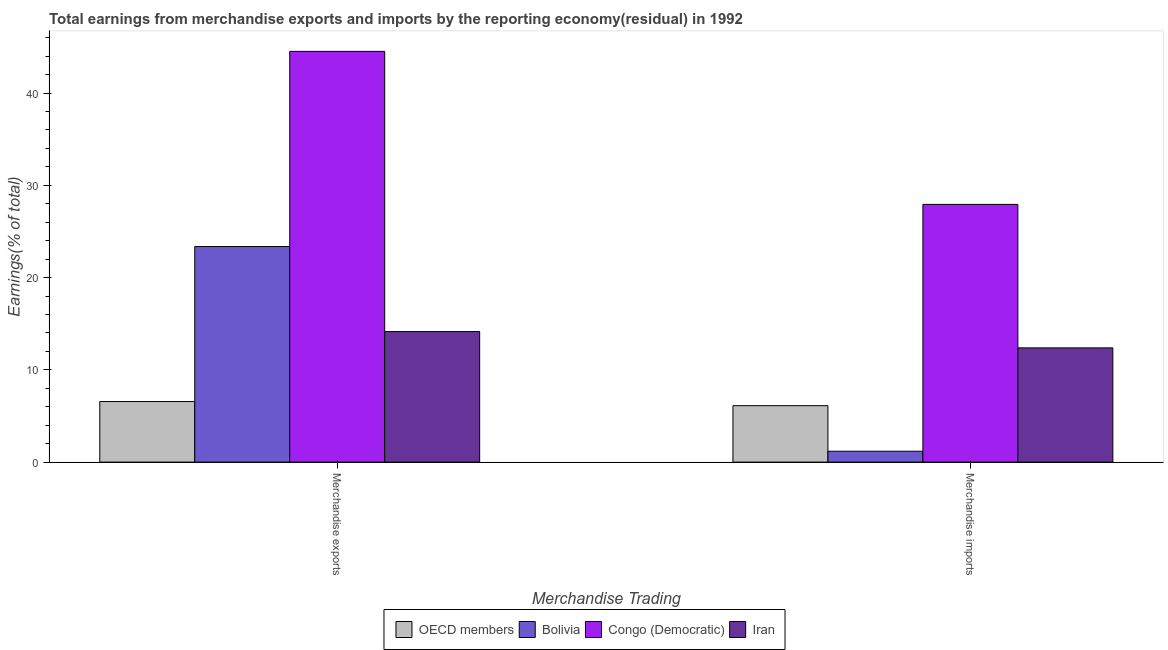How many different coloured bars are there?
Give a very brief answer. 4. How many groups of bars are there?
Provide a succinct answer. 2. Are the number of bars per tick equal to the number of legend labels?
Offer a terse response. Yes. Are the number of bars on each tick of the X-axis equal?
Offer a terse response. Yes. How many bars are there on the 1st tick from the left?
Your response must be concise. 4. How many bars are there on the 1st tick from the right?
Your answer should be compact. 4. What is the earnings from merchandise exports in Bolivia?
Offer a terse response. 23.36. Across all countries, what is the maximum earnings from merchandise imports?
Provide a short and direct response. 27.93. Across all countries, what is the minimum earnings from merchandise exports?
Provide a succinct answer. 6.57. In which country was the earnings from merchandise exports maximum?
Your answer should be compact. Congo (Democratic). In which country was the earnings from merchandise exports minimum?
Offer a very short reply. OECD members. What is the total earnings from merchandise exports in the graph?
Your answer should be compact. 88.58. What is the difference between the earnings from merchandise imports in OECD members and that in Congo (Democratic)?
Keep it short and to the point. -21.81. What is the difference between the earnings from merchandise exports in Bolivia and the earnings from merchandise imports in OECD members?
Provide a succinct answer. 17.24. What is the average earnings from merchandise exports per country?
Offer a terse response. 22.15. What is the difference between the earnings from merchandise exports and earnings from merchandise imports in OECD members?
Give a very brief answer. 0.45. What is the ratio of the earnings from merchandise exports in Bolivia to that in OECD members?
Your answer should be very brief. 3.56. In how many countries, is the earnings from merchandise exports greater than the average earnings from merchandise exports taken over all countries?
Ensure brevity in your answer.  2. What does the 3rd bar from the left in Merchandise exports represents?
Your answer should be compact. Congo (Democratic). What does the 1st bar from the right in Merchandise imports represents?
Offer a terse response. Iran. How many bars are there?
Offer a terse response. 8. What is the difference between two consecutive major ticks on the Y-axis?
Offer a very short reply. 10. Does the graph contain grids?
Provide a short and direct response. No. How many legend labels are there?
Offer a terse response. 4. How are the legend labels stacked?
Give a very brief answer. Horizontal. What is the title of the graph?
Your answer should be very brief. Total earnings from merchandise exports and imports by the reporting economy(residual) in 1992. Does "Poland" appear as one of the legend labels in the graph?
Your answer should be very brief. No. What is the label or title of the X-axis?
Your response must be concise. Merchandise Trading. What is the label or title of the Y-axis?
Provide a succinct answer. Earnings(% of total). What is the Earnings(% of total) in OECD members in Merchandise exports?
Make the answer very short. 6.57. What is the Earnings(% of total) in Bolivia in Merchandise exports?
Provide a succinct answer. 23.36. What is the Earnings(% of total) of Congo (Democratic) in Merchandise exports?
Ensure brevity in your answer.  44.51. What is the Earnings(% of total) of Iran in Merchandise exports?
Give a very brief answer. 14.15. What is the Earnings(% of total) in OECD members in Merchandise imports?
Give a very brief answer. 6.12. What is the Earnings(% of total) of Bolivia in Merchandise imports?
Provide a succinct answer. 1.18. What is the Earnings(% of total) in Congo (Democratic) in Merchandise imports?
Make the answer very short. 27.93. What is the Earnings(% of total) of Iran in Merchandise imports?
Your answer should be very brief. 12.38. Across all Merchandise Trading, what is the maximum Earnings(% of total) of OECD members?
Keep it short and to the point. 6.57. Across all Merchandise Trading, what is the maximum Earnings(% of total) of Bolivia?
Your answer should be compact. 23.36. Across all Merchandise Trading, what is the maximum Earnings(% of total) of Congo (Democratic)?
Offer a terse response. 44.51. Across all Merchandise Trading, what is the maximum Earnings(% of total) of Iran?
Offer a very short reply. 14.15. Across all Merchandise Trading, what is the minimum Earnings(% of total) in OECD members?
Your answer should be compact. 6.12. Across all Merchandise Trading, what is the minimum Earnings(% of total) of Bolivia?
Provide a short and direct response. 1.18. Across all Merchandise Trading, what is the minimum Earnings(% of total) of Congo (Democratic)?
Ensure brevity in your answer.  27.93. Across all Merchandise Trading, what is the minimum Earnings(% of total) of Iran?
Ensure brevity in your answer.  12.38. What is the total Earnings(% of total) of OECD members in the graph?
Your answer should be very brief. 12.68. What is the total Earnings(% of total) of Bolivia in the graph?
Your answer should be very brief. 24.54. What is the total Earnings(% of total) of Congo (Democratic) in the graph?
Your answer should be very brief. 72.44. What is the total Earnings(% of total) of Iran in the graph?
Keep it short and to the point. 26.53. What is the difference between the Earnings(% of total) in OECD members in Merchandise exports and that in Merchandise imports?
Keep it short and to the point. 0.45. What is the difference between the Earnings(% of total) of Bolivia in Merchandise exports and that in Merchandise imports?
Provide a succinct answer. 22.18. What is the difference between the Earnings(% of total) of Congo (Democratic) in Merchandise exports and that in Merchandise imports?
Make the answer very short. 16.58. What is the difference between the Earnings(% of total) in Iran in Merchandise exports and that in Merchandise imports?
Your response must be concise. 1.77. What is the difference between the Earnings(% of total) of OECD members in Merchandise exports and the Earnings(% of total) of Bolivia in Merchandise imports?
Your answer should be very brief. 5.39. What is the difference between the Earnings(% of total) in OECD members in Merchandise exports and the Earnings(% of total) in Congo (Democratic) in Merchandise imports?
Keep it short and to the point. -21.36. What is the difference between the Earnings(% of total) of OECD members in Merchandise exports and the Earnings(% of total) of Iran in Merchandise imports?
Give a very brief answer. -5.82. What is the difference between the Earnings(% of total) in Bolivia in Merchandise exports and the Earnings(% of total) in Congo (Democratic) in Merchandise imports?
Provide a short and direct response. -4.57. What is the difference between the Earnings(% of total) of Bolivia in Merchandise exports and the Earnings(% of total) of Iran in Merchandise imports?
Your response must be concise. 10.98. What is the difference between the Earnings(% of total) in Congo (Democratic) in Merchandise exports and the Earnings(% of total) in Iran in Merchandise imports?
Keep it short and to the point. 32.13. What is the average Earnings(% of total) in OECD members per Merchandise Trading?
Give a very brief answer. 6.34. What is the average Earnings(% of total) in Bolivia per Merchandise Trading?
Provide a short and direct response. 12.27. What is the average Earnings(% of total) of Congo (Democratic) per Merchandise Trading?
Provide a short and direct response. 36.22. What is the average Earnings(% of total) in Iran per Merchandise Trading?
Provide a short and direct response. 13.26. What is the difference between the Earnings(% of total) of OECD members and Earnings(% of total) of Bolivia in Merchandise exports?
Your answer should be very brief. -16.79. What is the difference between the Earnings(% of total) of OECD members and Earnings(% of total) of Congo (Democratic) in Merchandise exports?
Make the answer very short. -37.95. What is the difference between the Earnings(% of total) in OECD members and Earnings(% of total) in Iran in Merchandise exports?
Provide a succinct answer. -7.58. What is the difference between the Earnings(% of total) of Bolivia and Earnings(% of total) of Congo (Democratic) in Merchandise exports?
Provide a short and direct response. -21.15. What is the difference between the Earnings(% of total) of Bolivia and Earnings(% of total) of Iran in Merchandise exports?
Offer a very short reply. 9.21. What is the difference between the Earnings(% of total) in Congo (Democratic) and Earnings(% of total) in Iran in Merchandise exports?
Offer a very short reply. 30.37. What is the difference between the Earnings(% of total) in OECD members and Earnings(% of total) in Bolivia in Merchandise imports?
Your response must be concise. 4.94. What is the difference between the Earnings(% of total) of OECD members and Earnings(% of total) of Congo (Democratic) in Merchandise imports?
Provide a short and direct response. -21.81. What is the difference between the Earnings(% of total) of OECD members and Earnings(% of total) of Iran in Merchandise imports?
Offer a terse response. -6.26. What is the difference between the Earnings(% of total) in Bolivia and Earnings(% of total) in Congo (Democratic) in Merchandise imports?
Offer a terse response. -26.75. What is the difference between the Earnings(% of total) of Bolivia and Earnings(% of total) of Iran in Merchandise imports?
Keep it short and to the point. -11.2. What is the difference between the Earnings(% of total) of Congo (Democratic) and Earnings(% of total) of Iran in Merchandise imports?
Give a very brief answer. 15.55. What is the ratio of the Earnings(% of total) of OECD members in Merchandise exports to that in Merchandise imports?
Make the answer very short. 1.07. What is the ratio of the Earnings(% of total) of Bolivia in Merchandise exports to that in Merchandise imports?
Your answer should be compact. 19.79. What is the ratio of the Earnings(% of total) of Congo (Democratic) in Merchandise exports to that in Merchandise imports?
Offer a very short reply. 1.59. What is the ratio of the Earnings(% of total) of Iran in Merchandise exports to that in Merchandise imports?
Your answer should be compact. 1.14. What is the difference between the highest and the second highest Earnings(% of total) of OECD members?
Offer a terse response. 0.45. What is the difference between the highest and the second highest Earnings(% of total) in Bolivia?
Provide a short and direct response. 22.18. What is the difference between the highest and the second highest Earnings(% of total) in Congo (Democratic)?
Offer a very short reply. 16.58. What is the difference between the highest and the second highest Earnings(% of total) of Iran?
Give a very brief answer. 1.77. What is the difference between the highest and the lowest Earnings(% of total) in OECD members?
Give a very brief answer. 0.45. What is the difference between the highest and the lowest Earnings(% of total) in Bolivia?
Your answer should be very brief. 22.18. What is the difference between the highest and the lowest Earnings(% of total) in Congo (Democratic)?
Keep it short and to the point. 16.58. What is the difference between the highest and the lowest Earnings(% of total) of Iran?
Provide a succinct answer. 1.77. 